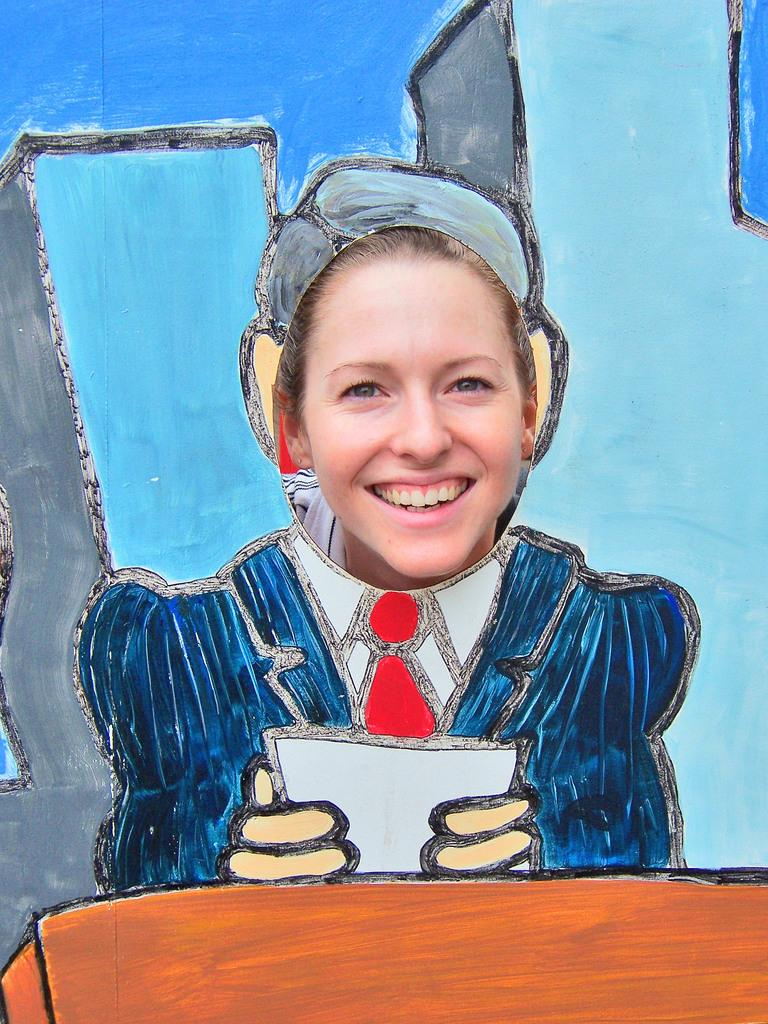What is present in the image? There is a person and a paper in the image. Can you describe the person in the image? Unfortunately, the provided facts do not give any details about the person's appearance or actions. What is the paper being used for in the image? The provided facts do not give any information about the purpose or context of the paper. What type of beast can be seen transporting the person in the image? There is no beast present in the image, nor is the person being transported by any means. 